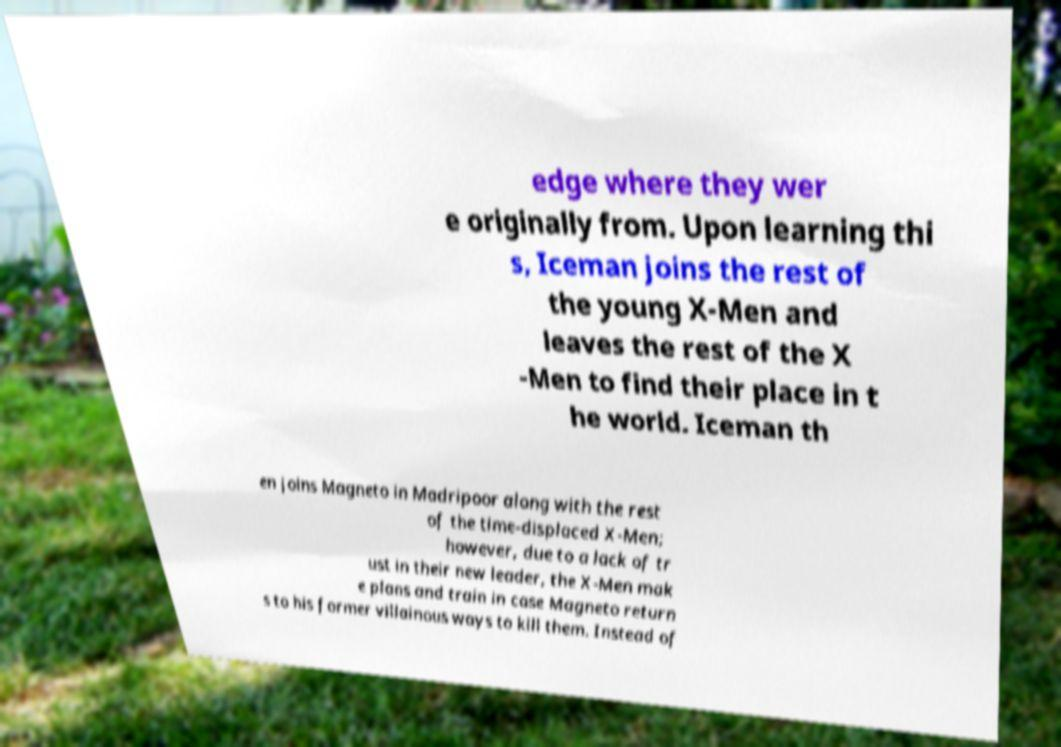Please identify and transcribe the text found in this image. edge where they wer e originally from. Upon learning thi s, Iceman joins the rest of the young X-Men and leaves the rest of the X -Men to find their place in t he world. Iceman th en joins Magneto in Madripoor along with the rest of the time-displaced X-Men; however, due to a lack of tr ust in their new leader, the X-Men mak e plans and train in case Magneto return s to his former villainous ways to kill them. Instead of 